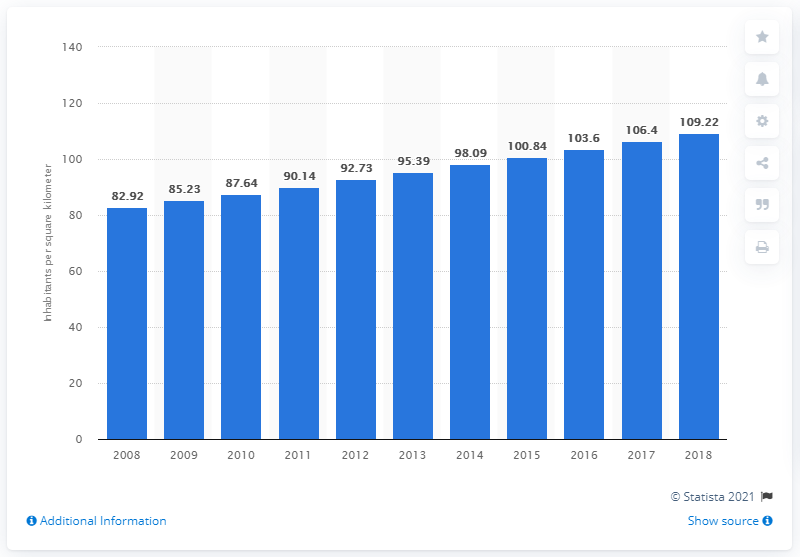Point out several critical features in this image. In 2018, Ethiopia's population density per square kilometer was reported to be 109.22. 